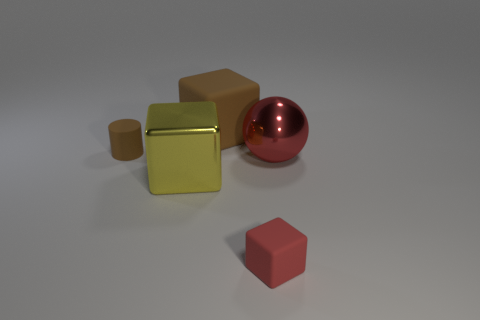Is there any other thing that has the same color as the sphere?
Keep it short and to the point. Yes. What is the thing that is both behind the large shiny sphere and on the right side of the small cylinder made of?
Keep it short and to the point. Rubber. There is a red metal ball; is it the same size as the matte object on the left side of the large brown matte block?
Ensure brevity in your answer.  No. Is there a big red thing?
Offer a terse response. Yes. There is a brown thing that is the same shape as the small red matte thing; what is its material?
Provide a succinct answer. Rubber. How big is the brown object that is behind the brown rubber cylinder behind the red thing right of the small red block?
Your response must be concise. Large. There is a large brown rubber cube; are there any brown blocks in front of it?
Your response must be concise. No. The red ball that is made of the same material as the yellow thing is what size?
Give a very brief answer. Large. What number of tiny gray matte things are the same shape as the big brown rubber thing?
Your answer should be compact. 0. Does the red block have the same material as the brown cylinder that is behind the tiny cube?
Give a very brief answer. Yes. 